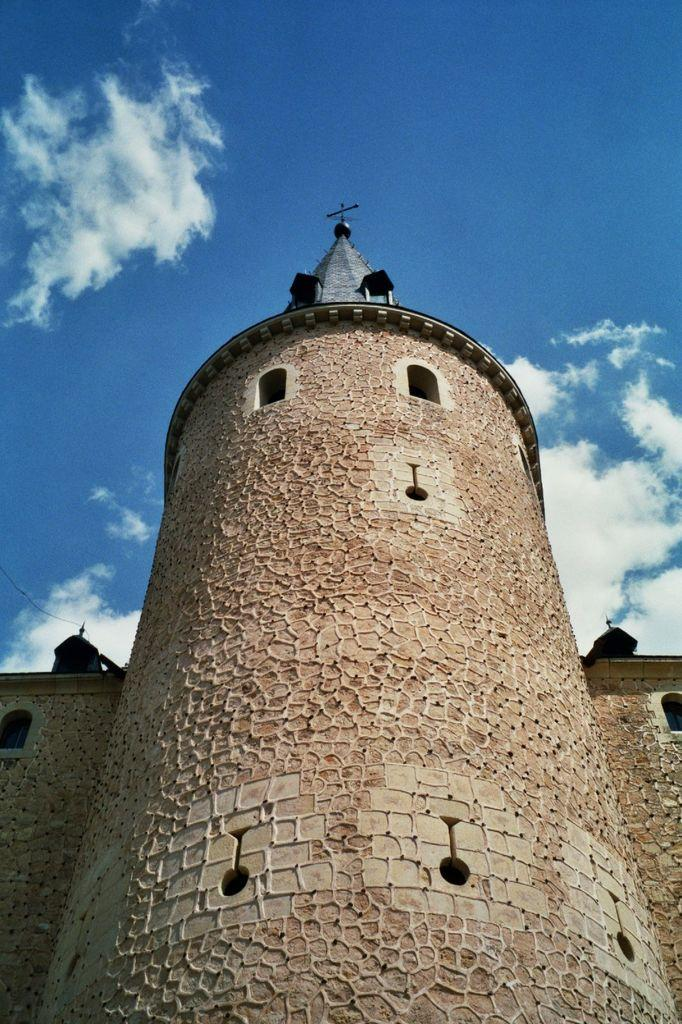What type of structure is depicted in the image? There is a structure that resembles a fort in the image. What can be seen at the top of the image? The sky is visible at the top of the image. How many stars can be seen in the image? There is no mention of stars in the image, so it is impossible to determine their number. 